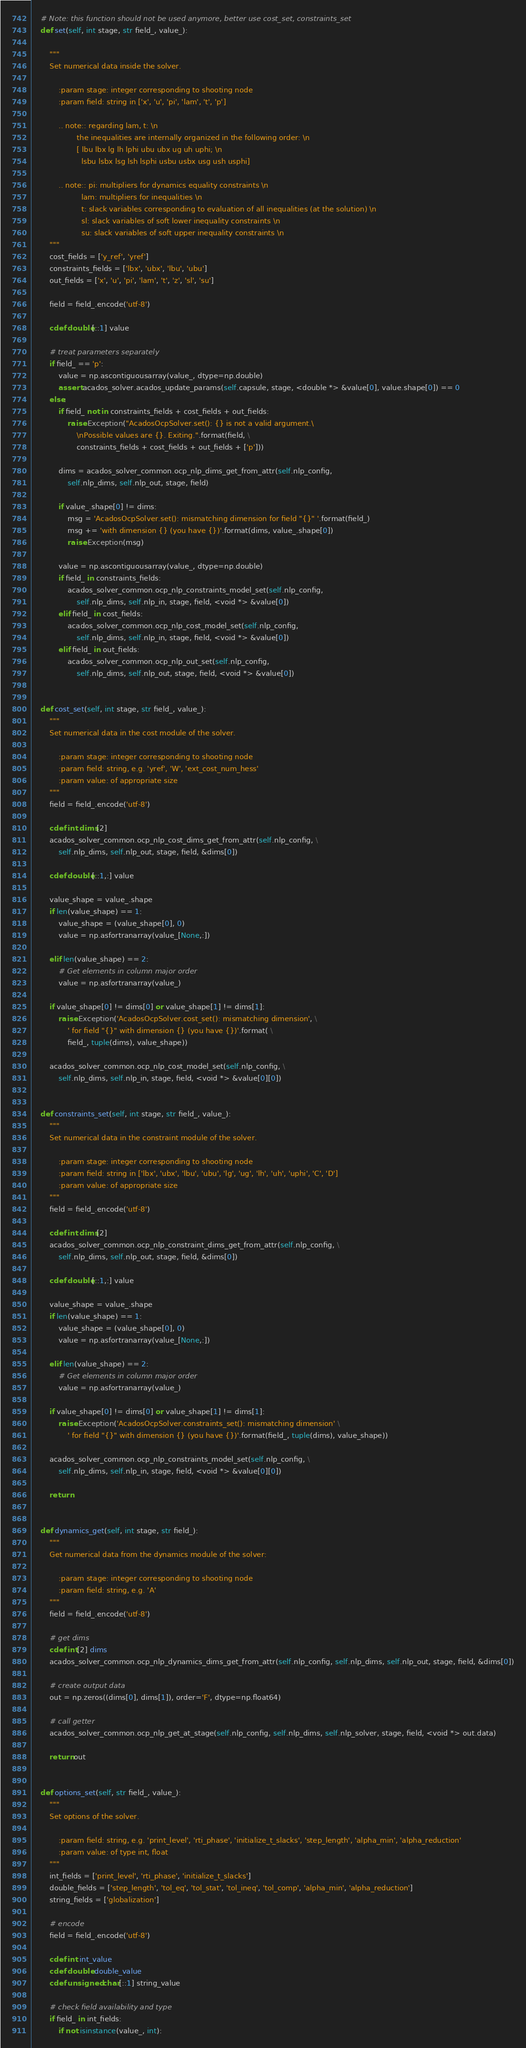<code> <loc_0><loc_0><loc_500><loc_500><_Cython_>
    # Note: this function should not be used anymore, better use cost_set, constraints_set
    def set(self, int stage, str field_, value_):

        """
        Set numerical data inside the solver.

            :param stage: integer corresponding to shooting node
            :param field: string in ['x', 'u', 'pi', 'lam', 't', 'p']

            .. note:: regarding lam, t: \n
                    the inequalities are internally organized in the following order: \n
                    [ lbu lbx lg lh lphi ubu ubx ug uh uphi; \n
                      lsbu lsbx lsg lsh lsphi usbu usbx usg ush usphi]

            .. note:: pi: multipliers for dynamics equality constraints \n
                      lam: multipliers for inequalities \n
                      t: slack variables corresponding to evaluation of all inequalities (at the solution) \n
                      sl: slack variables of soft lower inequality constraints \n
                      su: slack variables of soft upper inequality constraints \n
        """
        cost_fields = ['y_ref', 'yref']
        constraints_fields = ['lbx', 'ubx', 'lbu', 'ubu']
        out_fields = ['x', 'u', 'pi', 'lam', 't', 'z', 'sl', 'su']

        field = field_.encode('utf-8')

        cdef double[::1] value

        # treat parameters separately
        if field_ == 'p':
            value = np.ascontiguousarray(value_, dtype=np.double)
            assert acados_solver.acados_update_params(self.capsule, stage, <double *> &value[0], value.shape[0]) == 0
        else:
            if field_ not in constraints_fields + cost_fields + out_fields:
                raise Exception("AcadosOcpSolver.set(): {} is not a valid argument.\
                    \nPossible values are {}. Exiting.".format(field, \
                    constraints_fields + cost_fields + out_fields + ['p']))

            dims = acados_solver_common.ocp_nlp_dims_get_from_attr(self.nlp_config,
                self.nlp_dims, self.nlp_out, stage, field)

            if value_.shape[0] != dims:
                msg = 'AcadosOcpSolver.set(): mismatching dimension for field "{}" '.format(field_)
                msg += 'with dimension {} (you have {})'.format(dims, value_.shape[0])
                raise Exception(msg)

            value = np.ascontiguousarray(value_, dtype=np.double)
            if field_ in constraints_fields:
                acados_solver_common.ocp_nlp_constraints_model_set(self.nlp_config,
                    self.nlp_dims, self.nlp_in, stage, field, <void *> &value[0])
            elif field_ in cost_fields:
                acados_solver_common.ocp_nlp_cost_model_set(self.nlp_config,
                    self.nlp_dims, self.nlp_in, stage, field, <void *> &value[0])
            elif field_ in out_fields:
                acados_solver_common.ocp_nlp_out_set(self.nlp_config,
                    self.nlp_dims, self.nlp_out, stage, field, <void *> &value[0])


    def cost_set(self, int stage, str field_, value_):
        """
        Set numerical data in the cost module of the solver.

            :param stage: integer corresponding to shooting node
            :param field: string, e.g. 'yref', 'W', 'ext_cost_num_hess'
            :param value: of appropriate size
        """
        field = field_.encode('utf-8')

        cdef int dims[2]
        acados_solver_common.ocp_nlp_cost_dims_get_from_attr(self.nlp_config, \
            self.nlp_dims, self.nlp_out, stage, field, &dims[0])

        cdef double[::1,:] value

        value_shape = value_.shape
        if len(value_shape) == 1:
            value_shape = (value_shape[0], 0)
            value = np.asfortranarray(value_[None,:])

        elif len(value_shape) == 2:
            # Get elements in column major order
            value = np.asfortranarray(value_)

        if value_shape[0] != dims[0] or value_shape[1] != dims[1]:
            raise Exception('AcadosOcpSolver.cost_set(): mismatching dimension', \
                ' for field "{}" with dimension {} (you have {})'.format( \
                field_, tuple(dims), value_shape))

        acados_solver_common.ocp_nlp_cost_model_set(self.nlp_config, \
            self.nlp_dims, self.nlp_in, stage, field, <void *> &value[0][0])


    def constraints_set(self, int stage, str field_, value_):
        """
        Set numerical data in the constraint module of the solver.

            :param stage: integer corresponding to shooting node
            :param field: string in ['lbx', 'ubx', 'lbu', 'ubu', 'lg', 'ug', 'lh', 'uh', 'uphi', 'C', 'D']
            :param value: of appropriate size
        """
        field = field_.encode('utf-8')

        cdef int dims[2]
        acados_solver_common.ocp_nlp_constraint_dims_get_from_attr(self.nlp_config, \
            self.nlp_dims, self.nlp_out, stage, field, &dims[0])

        cdef double[::1,:] value

        value_shape = value_.shape
        if len(value_shape) == 1:
            value_shape = (value_shape[0], 0)
            value = np.asfortranarray(value_[None,:])

        elif len(value_shape) == 2:
            # Get elements in column major order
            value = np.asfortranarray(value_)

        if value_shape[0] != dims[0] or value_shape[1] != dims[1]:
            raise Exception('AcadosOcpSolver.constraints_set(): mismatching dimension' \
                ' for field "{}" with dimension {} (you have {})'.format(field_, tuple(dims), value_shape))

        acados_solver_common.ocp_nlp_constraints_model_set(self.nlp_config, \
            self.nlp_dims, self.nlp_in, stage, field, <void *> &value[0][0])

        return


    def dynamics_get(self, int stage, str field_):
        """
        Get numerical data from the dynamics module of the solver:

            :param stage: integer corresponding to shooting node
            :param field: string, e.g. 'A'
        """
        field = field_.encode('utf-8')

        # get dims
        cdef int[2] dims
        acados_solver_common.ocp_nlp_dynamics_dims_get_from_attr(self.nlp_config, self.nlp_dims, self.nlp_out, stage, field, &dims[0])

        # create output data
        out = np.zeros((dims[0], dims[1]), order='F', dtype=np.float64)

        # call getter
        acados_solver_common.ocp_nlp_get_at_stage(self.nlp_config, self.nlp_dims, self.nlp_solver, stage, field, <void *> out.data)

        return out


    def options_set(self, str field_, value_):
        """
        Set options of the solver.

            :param field: string, e.g. 'print_level', 'rti_phase', 'initialize_t_slacks', 'step_length', 'alpha_min', 'alpha_reduction'
            :param value: of type int, float
        """
        int_fields = ['print_level', 'rti_phase', 'initialize_t_slacks']
        double_fields = ['step_length', 'tol_eq', 'tol_stat', 'tol_ineq', 'tol_comp', 'alpha_min', 'alpha_reduction']
        string_fields = ['globalization']

        # encode
        field = field_.encode('utf-8')

        cdef int int_value
        cdef double double_value
        cdef unsigned char[::1] string_value

        # check field availability and type
        if field_ in int_fields:
            if not isinstance(value_, int):</code> 